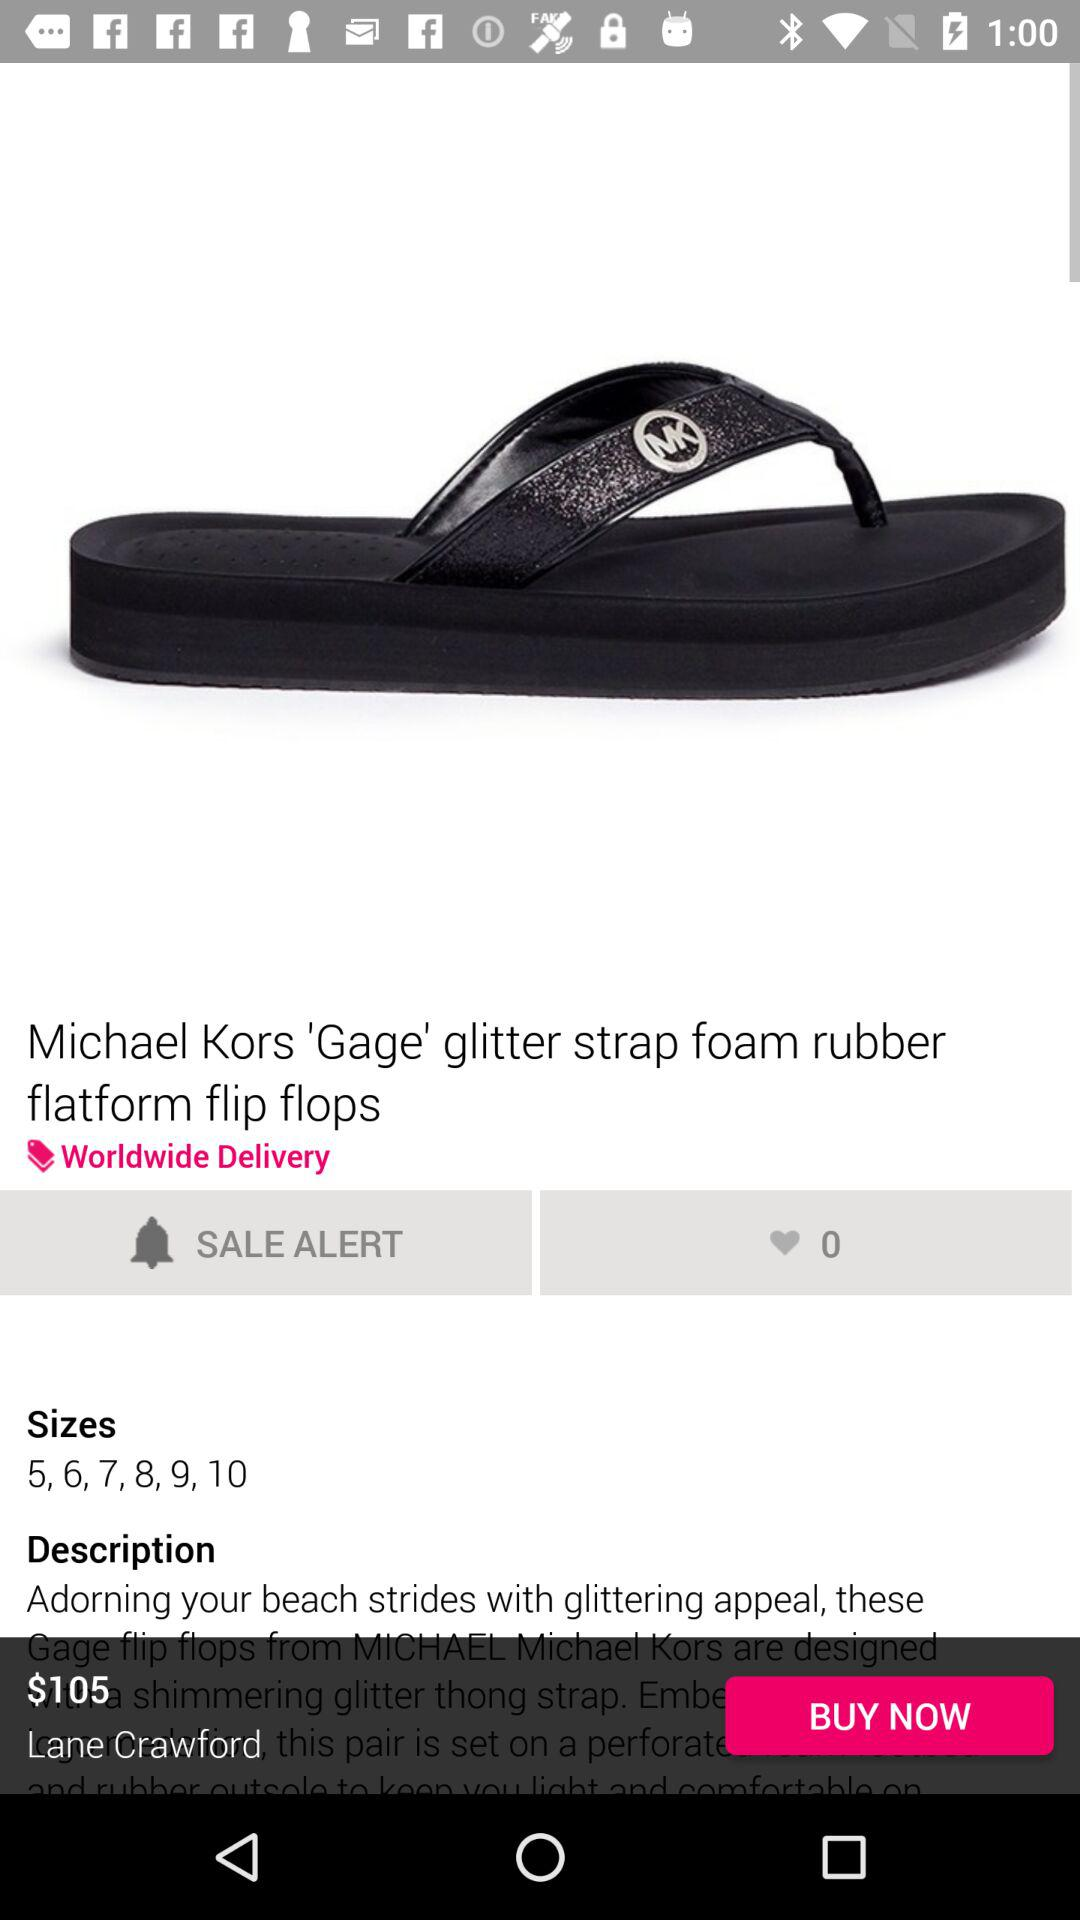How many sizes are available?
Answer the question using a single word or phrase. 6 